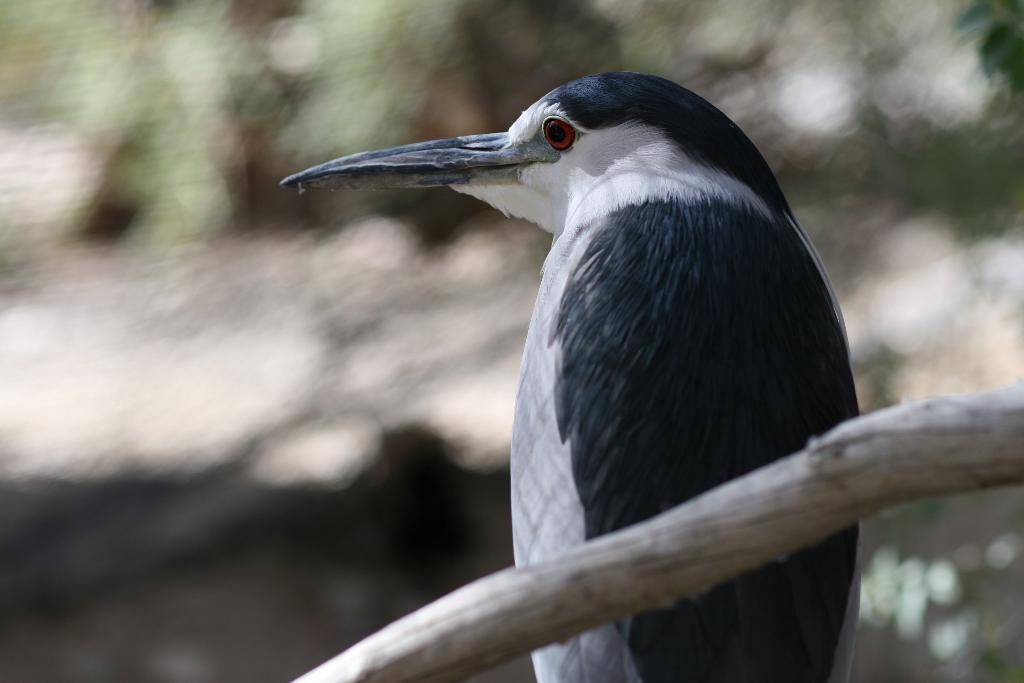How would you summarize this image in a sentence or two? In the picture I can see a bird. The background image is blurred. 